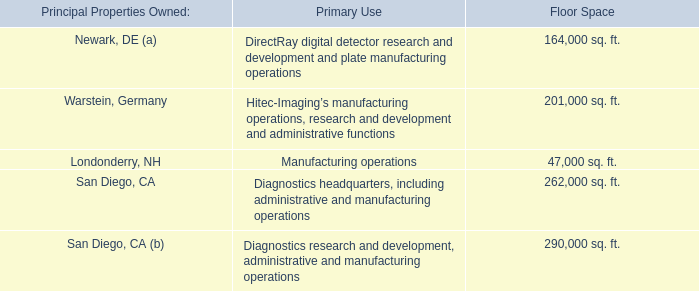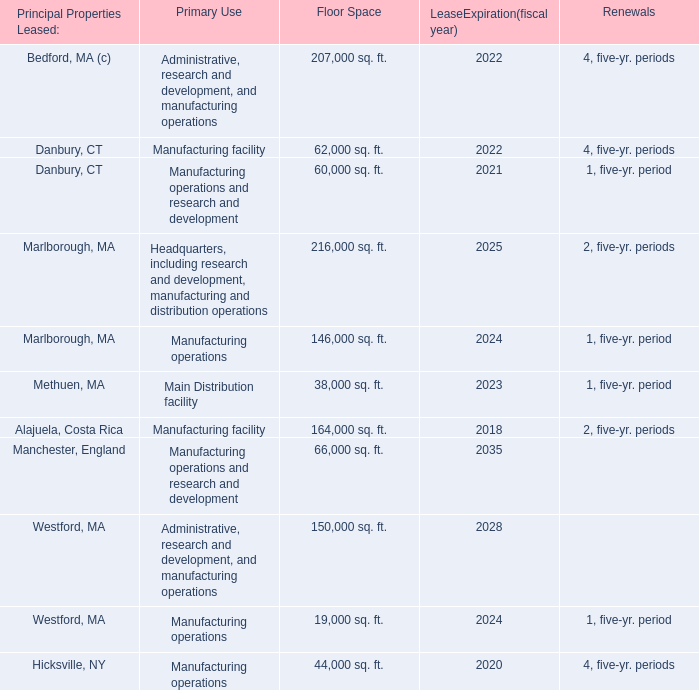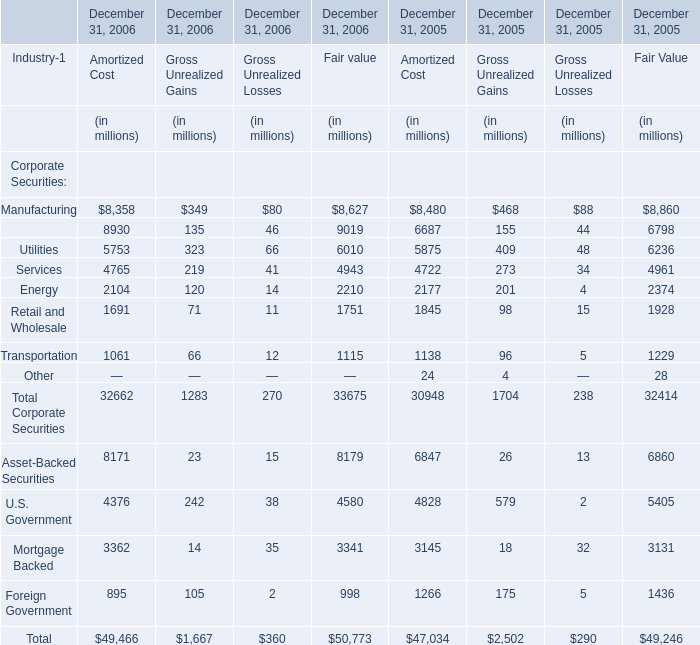What will the Gross Unrealized Gains for Total Corporate Securities on December 31 be like in 2007 if it develops with the same growth rate as in 2006? (in million) 
Computations: (1283 * (1 + ((1283 - 1704) / 1704)))
Answer: 966.01467. 